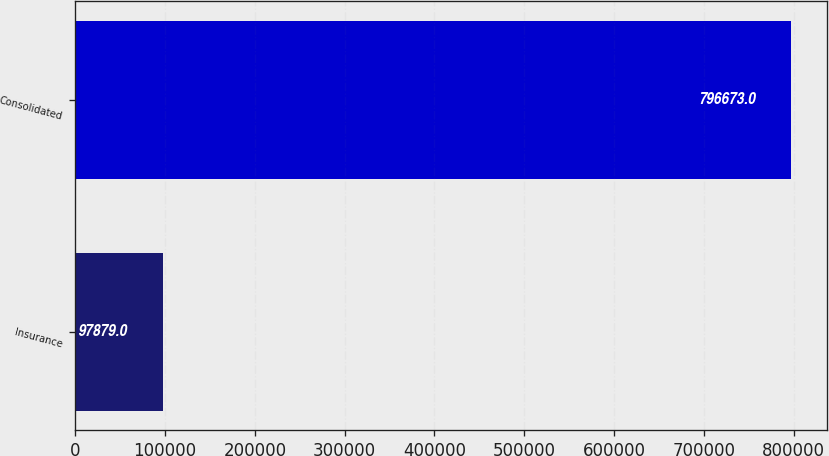<chart> <loc_0><loc_0><loc_500><loc_500><bar_chart><fcel>Insurance<fcel>Consolidated<nl><fcel>97879<fcel>796673<nl></chart> 